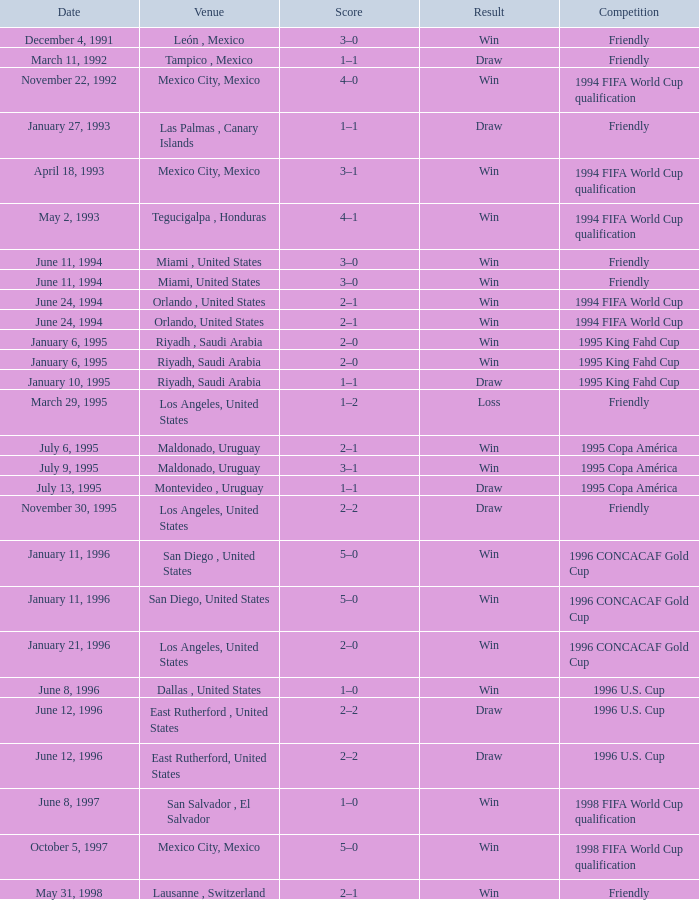What is the effect when the date is "june 11, 1994" and the place is "miami, united states"? Win, Win. Could you help me parse every detail presented in this table? {'header': ['Date', 'Venue', 'Score', 'Result', 'Competition'], 'rows': [['December 4, 1991', 'León , Mexico', '3–0', 'Win', 'Friendly'], ['March 11, 1992', 'Tampico , Mexico', '1–1', 'Draw', 'Friendly'], ['November 22, 1992', 'Mexico City, Mexico', '4–0', 'Win', '1994 FIFA World Cup qualification'], ['January 27, 1993', 'Las Palmas , Canary Islands', '1–1', 'Draw', 'Friendly'], ['April 18, 1993', 'Mexico City, Mexico', '3–1', 'Win', '1994 FIFA World Cup qualification'], ['May 2, 1993', 'Tegucigalpa , Honduras', '4–1', 'Win', '1994 FIFA World Cup qualification'], ['June 11, 1994', 'Miami , United States', '3–0', 'Win', 'Friendly'], ['June 11, 1994', 'Miami, United States', '3–0', 'Win', 'Friendly'], ['June 24, 1994', 'Orlando , United States', '2–1', 'Win', '1994 FIFA World Cup'], ['June 24, 1994', 'Orlando, United States', '2–1', 'Win', '1994 FIFA World Cup'], ['January 6, 1995', 'Riyadh , Saudi Arabia', '2–0', 'Win', '1995 King Fahd Cup'], ['January 6, 1995', 'Riyadh, Saudi Arabia', '2–0', 'Win', '1995 King Fahd Cup'], ['January 10, 1995', 'Riyadh, Saudi Arabia', '1–1', 'Draw', '1995 King Fahd Cup'], ['March 29, 1995', 'Los Angeles, United States', '1–2', 'Loss', 'Friendly'], ['July 6, 1995', 'Maldonado, Uruguay', '2–1', 'Win', '1995 Copa América'], ['July 9, 1995', 'Maldonado, Uruguay', '3–1', 'Win', '1995 Copa América'], ['July 13, 1995', 'Montevideo , Uruguay', '1–1', 'Draw', '1995 Copa América'], ['November 30, 1995', 'Los Angeles, United States', '2–2', 'Draw', 'Friendly'], ['January 11, 1996', 'San Diego , United States', '5–0', 'Win', '1996 CONCACAF Gold Cup'], ['January 11, 1996', 'San Diego, United States', '5–0', 'Win', '1996 CONCACAF Gold Cup'], ['January 21, 1996', 'Los Angeles, United States', '2–0', 'Win', '1996 CONCACAF Gold Cup'], ['June 8, 1996', 'Dallas , United States', '1–0', 'Win', '1996 U.S. Cup'], ['June 12, 1996', 'East Rutherford , United States', '2–2', 'Draw', '1996 U.S. Cup'], ['June 12, 1996', 'East Rutherford, United States', '2–2', 'Draw', '1996 U.S. Cup'], ['June 8, 1997', 'San Salvador , El Salvador', '1–0', 'Win', '1998 FIFA World Cup qualification'], ['October 5, 1997', 'Mexico City, Mexico', '5–0', 'Win', '1998 FIFA World Cup qualification'], ['May 31, 1998', 'Lausanne , Switzerland', '2–1', 'Win', 'Friendly']]} 